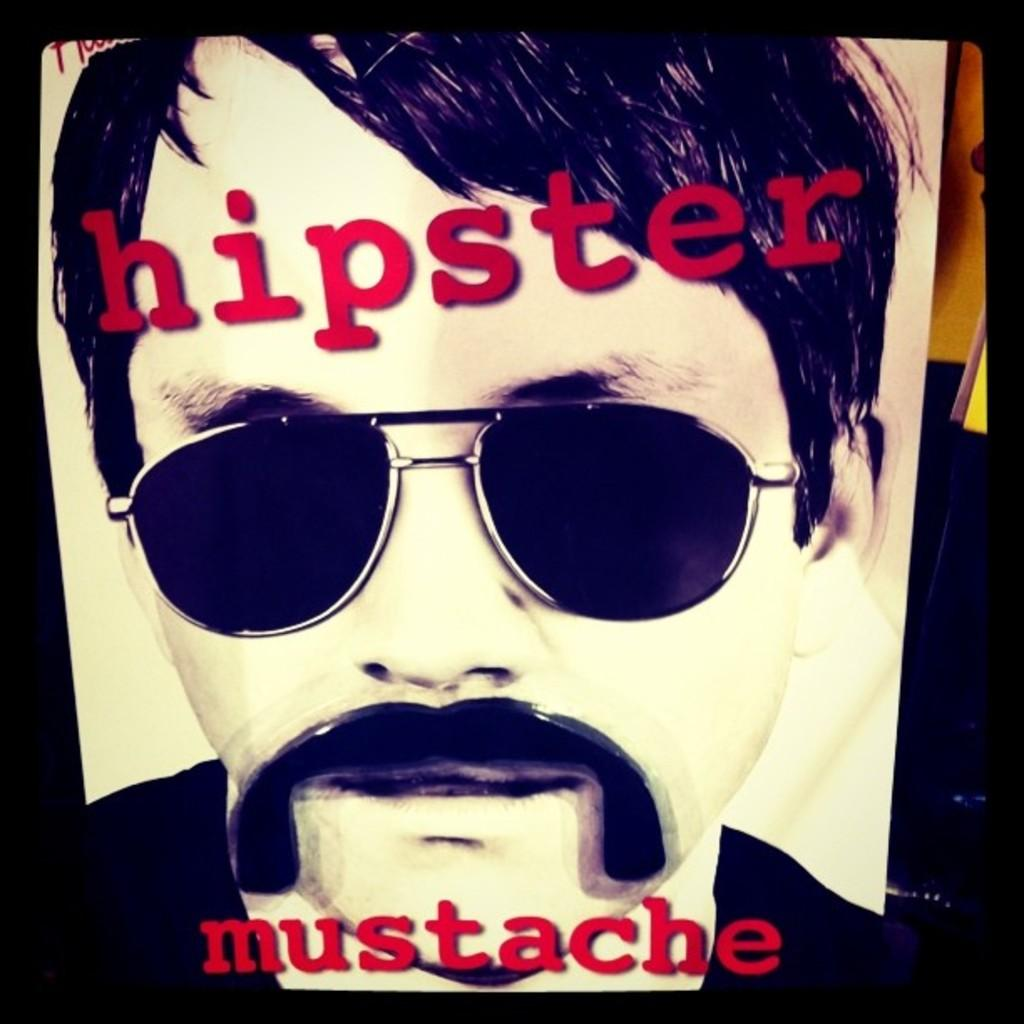What can be observed about the image itself? The image is edited. Who or what is present in the image? There is a person in the image. What accessory is the person wearing? The person is wearing spectacles. Where can text be found in the image? There is text at the bottom and top of the image. How does the salt expand in the image? There is no salt present in the image, so it cannot expand. What unit of measurement is used to determine the size of the person in the image? The image is not a photograph, and the person's size cannot be measured in this context. 